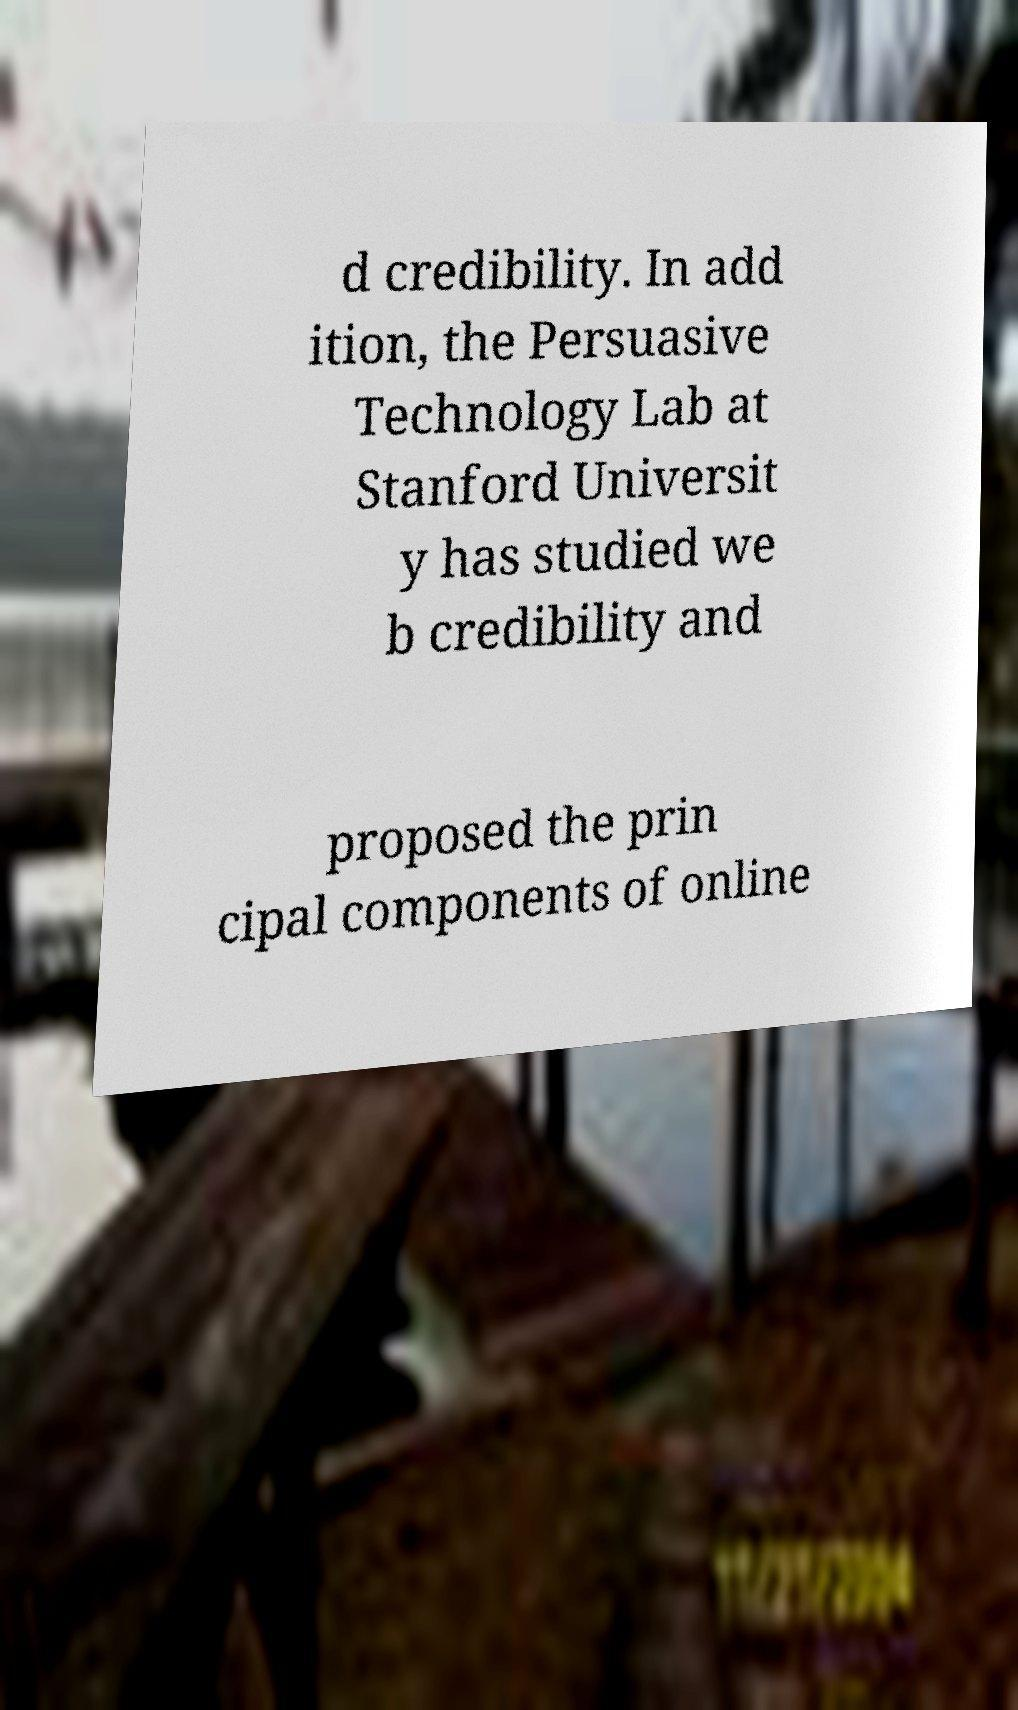Can you read and provide the text displayed in the image?This photo seems to have some interesting text. Can you extract and type it out for me? d credibility. In add ition, the Persuasive Technology Lab at Stanford Universit y has studied we b credibility and proposed the prin cipal components of online 